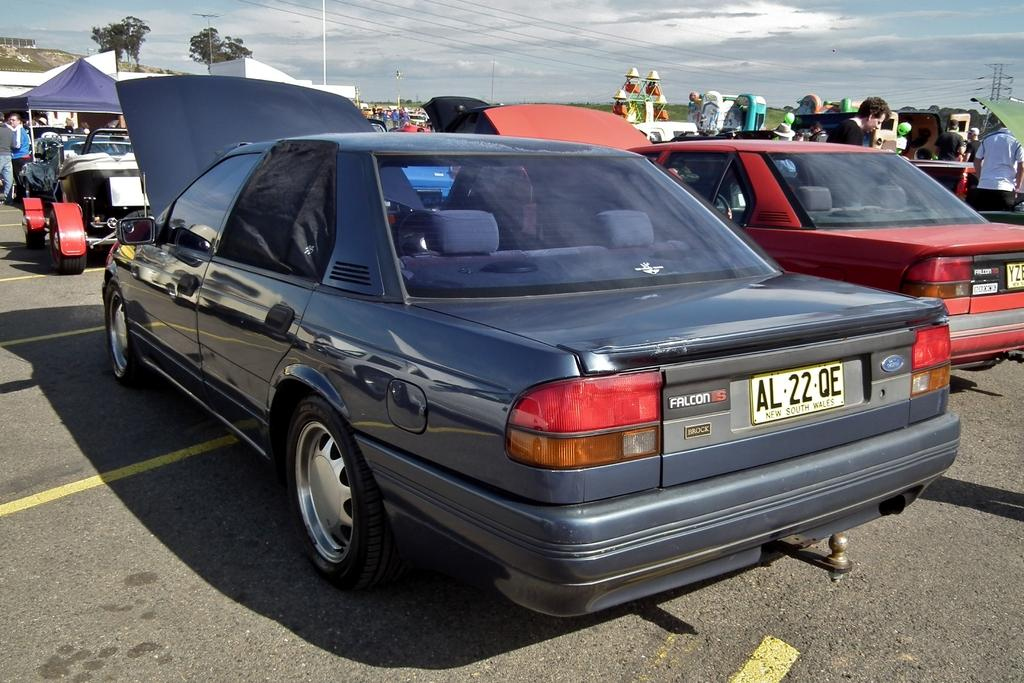What types of objects are present in the image? There are vehicles, many people, tents, and an amusement ride in the image. Can you describe the setting of the image? The image appears to be set in an outdoor area with tents in the background. What is visible in the sky in the image? The sky with clouds is visible in the background of the image. How much butter is being used in the image? There is no butter present in the image. What type of cloud is depicted in the image? The image does not depict a specific type of cloud; it simply shows clouds in the sky. 